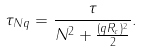Convert formula to latex. <formula><loc_0><loc_0><loc_500><loc_500>\tau _ { N q } = \frac { \tau } { N ^ { 2 } + \frac { ( q R _ { c } ) ^ { 2 } } { 2 } } .</formula> 